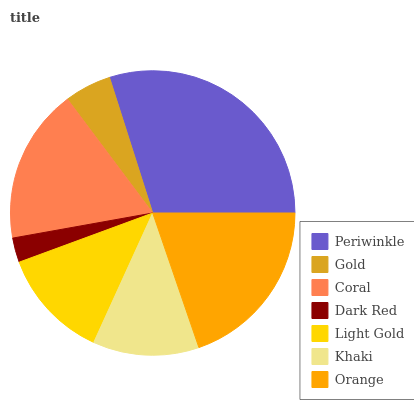Is Dark Red the minimum?
Answer yes or no. Yes. Is Periwinkle the maximum?
Answer yes or no. Yes. Is Gold the minimum?
Answer yes or no. No. Is Gold the maximum?
Answer yes or no. No. Is Periwinkle greater than Gold?
Answer yes or no. Yes. Is Gold less than Periwinkle?
Answer yes or no. Yes. Is Gold greater than Periwinkle?
Answer yes or no. No. Is Periwinkle less than Gold?
Answer yes or no. No. Is Light Gold the high median?
Answer yes or no. Yes. Is Light Gold the low median?
Answer yes or no. Yes. Is Dark Red the high median?
Answer yes or no. No. Is Dark Red the low median?
Answer yes or no. No. 